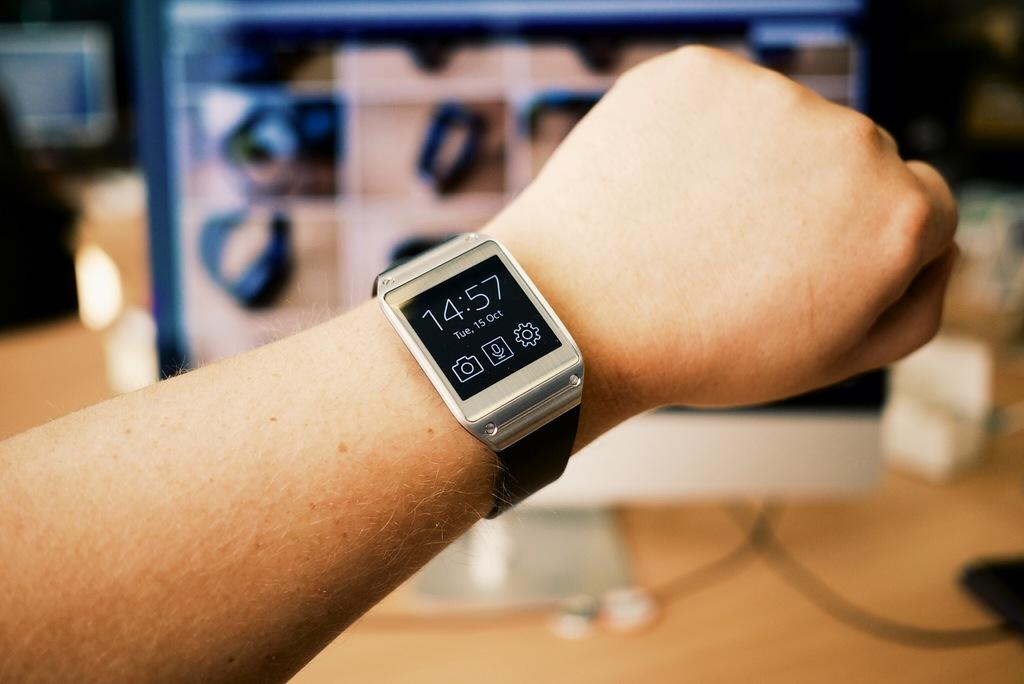<image>
Describe the image concisely. A wrist wearing a smart watch with the time 14:57 on Tuesday, Oct. 15. 